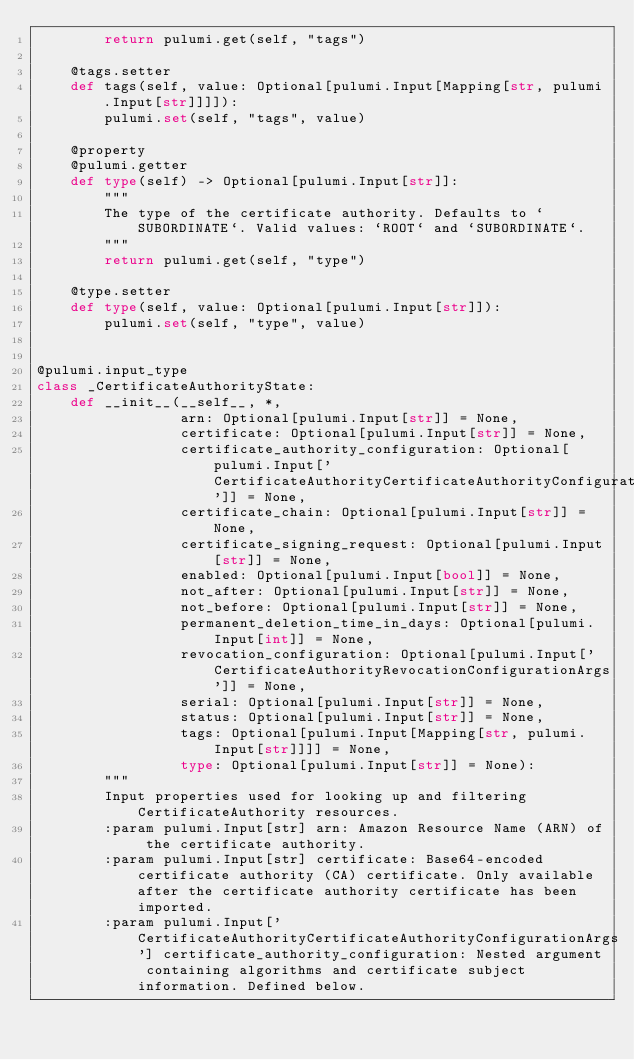Convert code to text. <code><loc_0><loc_0><loc_500><loc_500><_Python_>        return pulumi.get(self, "tags")

    @tags.setter
    def tags(self, value: Optional[pulumi.Input[Mapping[str, pulumi.Input[str]]]]):
        pulumi.set(self, "tags", value)

    @property
    @pulumi.getter
    def type(self) -> Optional[pulumi.Input[str]]:
        """
        The type of the certificate authority. Defaults to `SUBORDINATE`. Valid values: `ROOT` and `SUBORDINATE`.
        """
        return pulumi.get(self, "type")

    @type.setter
    def type(self, value: Optional[pulumi.Input[str]]):
        pulumi.set(self, "type", value)


@pulumi.input_type
class _CertificateAuthorityState:
    def __init__(__self__, *,
                 arn: Optional[pulumi.Input[str]] = None,
                 certificate: Optional[pulumi.Input[str]] = None,
                 certificate_authority_configuration: Optional[pulumi.Input['CertificateAuthorityCertificateAuthorityConfigurationArgs']] = None,
                 certificate_chain: Optional[pulumi.Input[str]] = None,
                 certificate_signing_request: Optional[pulumi.Input[str]] = None,
                 enabled: Optional[pulumi.Input[bool]] = None,
                 not_after: Optional[pulumi.Input[str]] = None,
                 not_before: Optional[pulumi.Input[str]] = None,
                 permanent_deletion_time_in_days: Optional[pulumi.Input[int]] = None,
                 revocation_configuration: Optional[pulumi.Input['CertificateAuthorityRevocationConfigurationArgs']] = None,
                 serial: Optional[pulumi.Input[str]] = None,
                 status: Optional[pulumi.Input[str]] = None,
                 tags: Optional[pulumi.Input[Mapping[str, pulumi.Input[str]]]] = None,
                 type: Optional[pulumi.Input[str]] = None):
        """
        Input properties used for looking up and filtering CertificateAuthority resources.
        :param pulumi.Input[str] arn: Amazon Resource Name (ARN) of the certificate authority.
        :param pulumi.Input[str] certificate: Base64-encoded certificate authority (CA) certificate. Only available after the certificate authority certificate has been imported.
        :param pulumi.Input['CertificateAuthorityCertificateAuthorityConfigurationArgs'] certificate_authority_configuration: Nested argument containing algorithms and certificate subject information. Defined below.</code> 